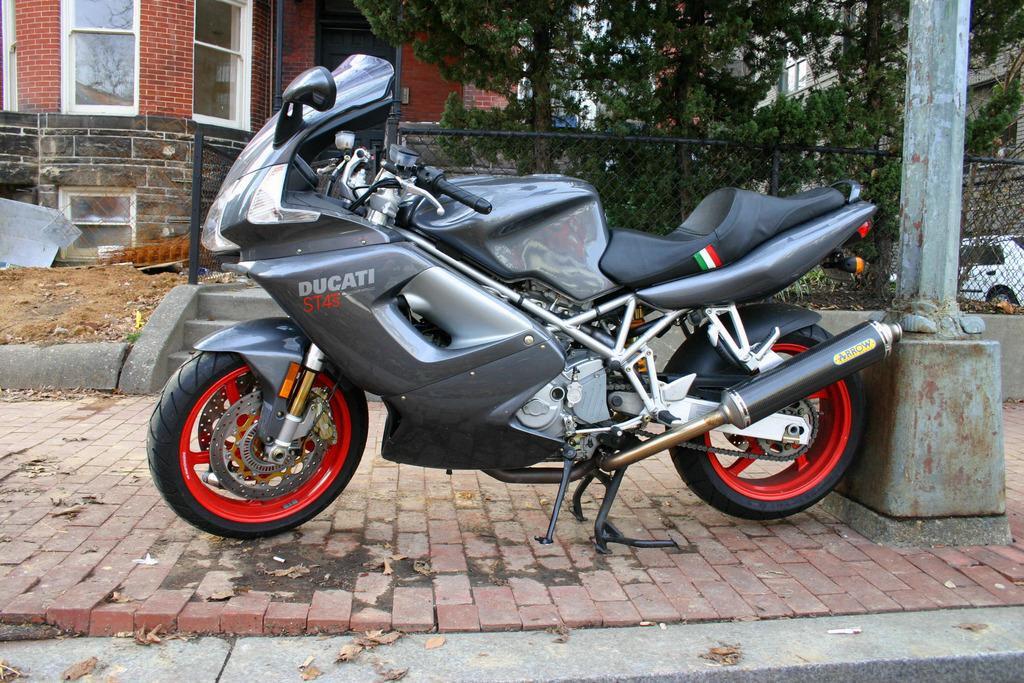What is the main subject in the middle of the image? There is a motor vehicle in the middle of the image. How is the motor vehicle positioned in the image? The motor vehicle is placed on the floor. What can be seen in the background of the image? There is an iron mesh, a pole, sand, shredded leaves, trees, buildings, and a car in the background of the image. What type of knowledge is being shared between the motor vehicle and the car in the image? There is no indication of knowledge being shared between the motor vehicle and the car in the image, as they are inanimate objects. 